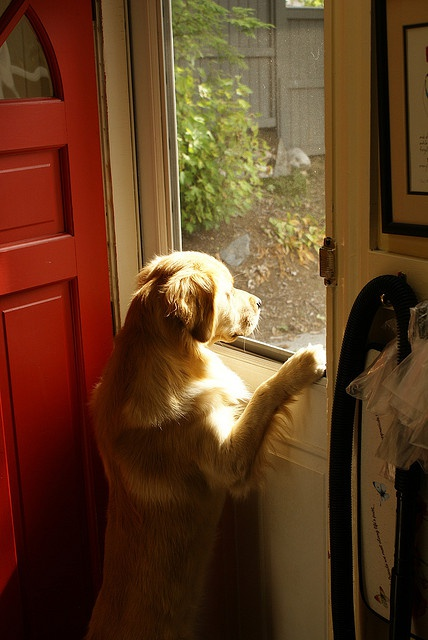Describe the objects in this image and their specific colors. I can see a dog in black, maroon, beige, and olive tones in this image. 